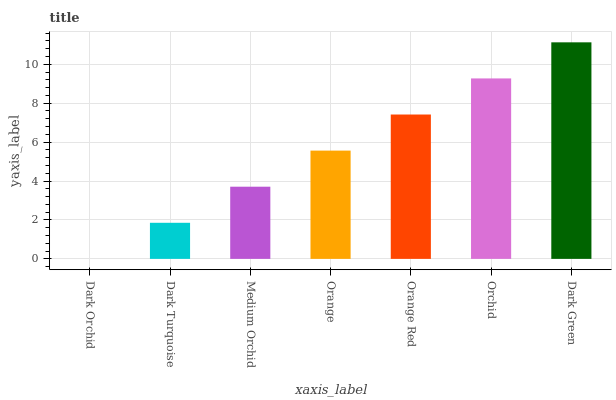Is Dark Turquoise the minimum?
Answer yes or no. No. Is Dark Turquoise the maximum?
Answer yes or no. No. Is Dark Turquoise greater than Dark Orchid?
Answer yes or no. Yes. Is Dark Orchid less than Dark Turquoise?
Answer yes or no. Yes. Is Dark Orchid greater than Dark Turquoise?
Answer yes or no. No. Is Dark Turquoise less than Dark Orchid?
Answer yes or no. No. Is Orange the high median?
Answer yes or no. Yes. Is Orange the low median?
Answer yes or no. Yes. Is Dark Turquoise the high median?
Answer yes or no. No. Is Orange Red the low median?
Answer yes or no. No. 